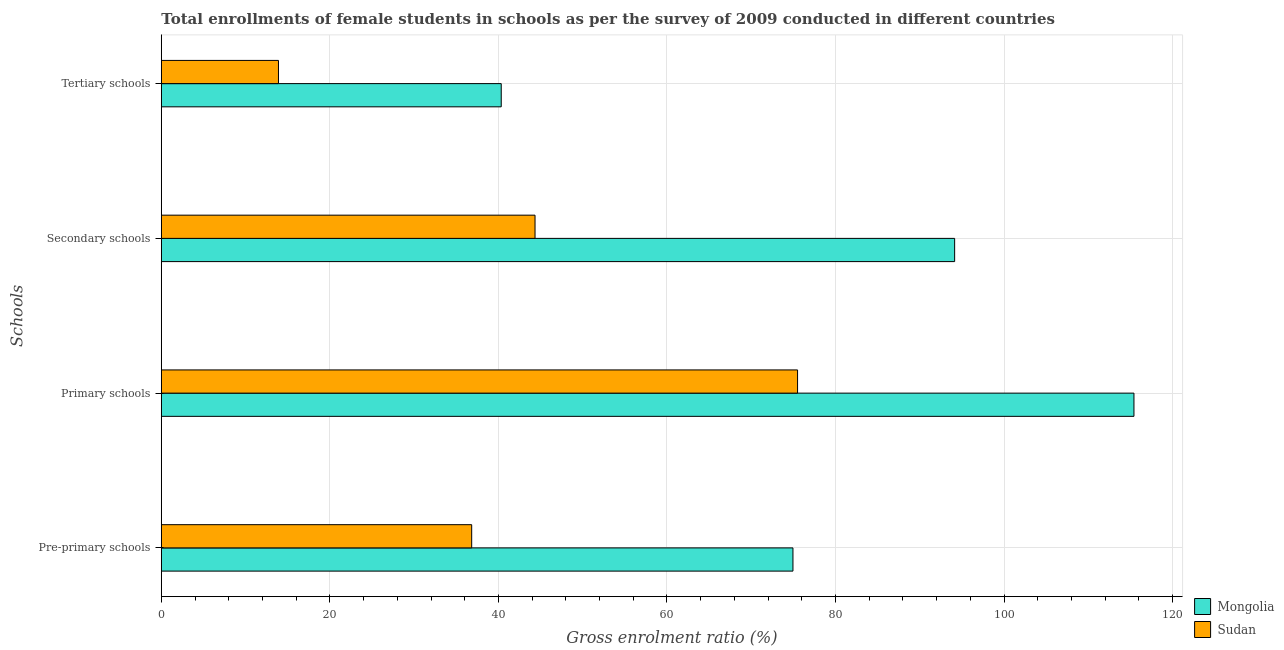How many different coloured bars are there?
Provide a succinct answer. 2. How many groups of bars are there?
Offer a terse response. 4. Are the number of bars on each tick of the Y-axis equal?
Your answer should be compact. Yes. What is the label of the 3rd group of bars from the top?
Offer a very short reply. Primary schools. What is the gross enrolment ratio(female) in primary schools in Sudan?
Keep it short and to the point. 75.5. Across all countries, what is the maximum gross enrolment ratio(female) in pre-primary schools?
Make the answer very short. 74.95. Across all countries, what is the minimum gross enrolment ratio(female) in tertiary schools?
Your response must be concise. 13.9. In which country was the gross enrolment ratio(female) in pre-primary schools maximum?
Your response must be concise. Mongolia. In which country was the gross enrolment ratio(female) in tertiary schools minimum?
Ensure brevity in your answer.  Sudan. What is the total gross enrolment ratio(female) in pre-primary schools in the graph?
Your answer should be very brief. 111.78. What is the difference between the gross enrolment ratio(female) in tertiary schools in Sudan and that in Mongolia?
Your response must be concise. -26.43. What is the difference between the gross enrolment ratio(female) in secondary schools in Sudan and the gross enrolment ratio(female) in tertiary schools in Mongolia?
Your answer should be compact. 4.01. What is the average gross enrolment ratio(female) in primary schools per country?
Provide a succinct answer. 95.46. What is the difference between the gross enrolment ratio(female) in primary schools and gross enrolment ratio(female) in secondary schools in Mongolia?
Your answer should be very brief. 21.28. What is the ratio of the gross enrolment ratio(female) in primary schools in Mongolia to that in Sudan?
Offer a terse response. 1.53. Is the gross enrolment ratio(female) in pre-primary schools in Mongolia less than that in Sudan?
Make the answer very short. No. Is the difference between the gross enrolment ratio(female) in primary schools in Sudan and Mongolia greater than the difference between the gross enrolment ratio(female) in secondary schools in Sudan and Mongolia?
Provide a succinct answer. Yes. What is the difference between the highest and the second highest gross enrolment ratio(female) in pre-primary schools?
Keep it short and to the point. 38.12. What is the difference between the highest and the lowest gross enrolment ratio(female) in pre-primary schools?
Your response must be concise. 38.12. In how many countries, is the gross enrolment ratio(female) in pre-primary schools greater than the average gross enrolment ratio(female) in pre-primary schools taken over all countries?
Your answer should be compact. 1. Is the sum of the gross enrolment ratio(female) in primary schools in Sudan and Mongolia greater than the maximum gross enrolment ratio(female) in secondary schools across all countries?
Offer a very short reply. Yes. What does the 1st bar from the top in Primary schools represents?
Offer a very short reply. Sudan. What does the 2nd bar from the bottom in Pre-primary schools represents?
Give a very brief answer. Sudan. Is it the case that in every country, the sum of the gross enrolment ratio(female) in pre-primary schools and gross enrolment ratio(female) in primary schools is greater than the gross enrolment ratio(female) in secondary schools?
Your response must be concise. Yes. How many bars are there?
Ensure brevity in your answer.  8. Are all the bars in the graph horizontal?
Make the answer very short. Yes. How many countries are there in the graph?
Provide a short and direct response. 2. What is the difference between two consecutive major ticks on the X-axis?
Offer a terse response. 20. Are the values on the major ticks of X-axis written in scientific E-notation?
Ensure brevity in your answer.  No. Does the graph contain any zero values?
Your response must be concise. No. Does the graph contain grids?
Ensure brevity in your answer.  Yes. How many legend labels are there?
Offer a very short reply. 2. How are the legend labels stacked?
Your answer should be very brief. Vertical. What is the title of the graph?
Ensure brevity in your answer.  Total enrollments of female students in schools as per the survey of 2009 conducted in different countries. Does "Japan" appear as one of the legend labels in the graph?
Keep it short and to the point. No. What is the label or title of the X-axis?
Your answer should be very brief. Gross enrolment ratio (%). What is the label or title of the Y-axis?
Provide a short and direct response. Schools. What is the Gross enrolment ratio (%) of Mongolia in Pre-primary schools?
Provide a succinct answer. 74.95. What is the Gross enrolment ratio (%) in Sudan in Pre-primary schools?
Keep it short and to the point. 36.83. What is the Gross enrolment ratio (%) in Mongolia in Primary schools?
Make the answer very short. 115.41. What is the Gross enrolment ratio (%) in Sudan in Primary schools?
Offer a very short reply. 75.5. What is the Gross enrolment ratio (%) of Mongolia in Secondary schools?
Offer a very short reply. 94.14. What is the Gross enrolment ratio (%) in Sudan in Secondary schools?
Offer a very short reply. 44.35. What is the Gross enrolment ratio (%) of Mongolia in Tertiary schools?
Ensure brevity in your answer.  40.33. What is the Gross enrolment ratio (%) in Sudan in Tertiary schools?
Your answer should be compact. 13.9. Across all Schools, what is the maximum Gross enrolment ratio (%) in Mongolia?
Your answer should be compact. 115.41. Across all Schools, what is the maximum Gross enrolment ratio (%) of Sudan?
Offer a very short reply. 75.5. Across all Schools, what is the minimum Gross enrolment ratio (%) in Mongolia?
Ensure brevity in your answer.  40.33. Across all Schools, what is the minimum Gross enrolment ratio (%) in Sudan?
Your response must be concise. 13.9. What is the total Gross enrolment ratio (%) of Mongolia in the graph?
Give a very brief answer. 324.83. What is the total Gross enrolment ratio (%) in Sudan in the graph?
Keep it short and to the point. 170.57. What is the difference between the Gross enrolment ratio (%) in Mongolia in Pre-primary schools and that in Primary schools?
Provide a short and direct response. -40.46. What is the difference between the Gross enrolment ratio (%) in Sudan in Pre-primary schools and that in Primary schools?
Offer a very short reply. -38.67. What is the difference between the Gross enrolment ratio (%) of Mongolia in Pre-primary schools and that in Secondary schools?
Provide a succinct answer. -19.19. What is the difference between the Gross enrolment ratio (%) in Sudan in Pre-primary schools and that in Secondary schools?
Offer a terse response. -7.52. What is the difference between the Gross enrolment ratio (%) in Mongolia in Pre-primary schools and that in Tertiary schools?
Provide a succinct answer. 34.62. What is the difference between the Gross enrolment ratio (%) in Sudan in Pre-primary schools and that in Tertiary schools?
Offer a terse response. 22.93. What is the difference between the Gross enrolment ratio (%) of Mongolia in Primary schools and that in Secondary schools?
Ensure brevity in your answer.  21.28. What is the difference between the Gross enrolment ratio (%) in Sudan in Primary schools and that in Secondary schools?
Your response must be concise. 31.15. What is the difference between the Gross enrolment ratio (%) in Mongolia in Primary schools and that in Tertiary schools?
Provide a short and direct response. 75.08. What is the difference between the Gross enrolment ratio (%) of Sudan in Primary schools and that in Tertiary schools?
Make the answer very short. 61.6. What is the difference between the Gross enrolment ratio (%) in Mongolia in Secondary schools and that in Tertiary schools?
Ensure brevity in your answer.  53.8. What is the difference between the Gross enrolment ratio (%) of Sudan in Secondary schools and that in Tertiary schools?
Your answer should be very brief. 30.44. What is the difference between the Gross enrolment ratio (%) of Mongolia in Pre-primary schools and the Gross enrolment ratio (%) of Sudan in Primary schools?
Make the answer very short. -0.55. What is the difference between the Gross enrolment ratio (%) of Mongolia in Pre-primary schools and the Gross enrolment ratio (%) of Sudan in Secondary schools?
Provide a short and direct response. 30.6. What is the difference between the Gross enrolment ratio (%) in Mongolia in Pre-primary schools and the Gross enrolment ratio (%) in Sudan in Tertiary schools?
Provide a succinct answer. 61.05. What is the difference between the Gross enrolment ratio (%) in Mongolia in Primary schools and the Gross enrolment ratio (%) in Sudan in Secondary schools?
Your response must be concise. 71.07. What is the difference between the Gross enrolment ratio (%) in Mongolia in Primary schools and the Gross enrolment ratio (%) in Sudan in Tertiary schools?
Ensure brevity in your answer.  101.51. What is the difference between the Gross enrolment ratio (%) in Mongolia in Secondary schools and the Gross enrolment ratio (%) in Sudan in Tertiary schools?
Offer a very short reply. 80.23. What is the average Gross enrolment ratio (%) of Mongolia per Schools?
Your answer should be compact. 81.21. What is the average Gross enrolment ratio (%) in Sudan per Schools?
Ensure brevity in your answer.  42.64. What is the difference between the Gross enrolment ratio (%) in Mongolia and Gross enrolment ratio (%) in Sudan in Pre-primary schools?
Give a very brief answer. 38.12. What is the difference between the Gross enrolment ratio (%) of Mongolia and Gross enrolment ratio (%) of Sudan in Primary schools?
Give a very brief answer. 39.92. What is the difference between the Gross enrolment ratio (%) of Mongolia and Gross enrolment ratio (%) of Sudan in Secondary schools?
Your answer should be compact. 49.79. What is the difference between the Gross enrolment ratio (%) of Mongolia and Gross enrolment ratio (%) of Sudan in Tertiary schools?
Offer a terse response. 26.43. What is the ratio of the Gross enrolment ratio (%) of Mongolia in Pre-primary schools to that in Primary schools?
Keep it short and to the point. 0.65. What is the ratio of the Gross enrolment ratio (%) of Sudan in Pre-primary schools to that in Primary schools?
Offer a terse response. 0.49. What is the ratio of the Gross enrolment ratio (%) in Mongolia in Pre-primary schools to that in Secondary schools?
Ensure brevity in your answer.  0.8. What is the ratio of the Gross enrolment ratio (%) of Sudan in Pre-primary schools to that in Secondary schools?
Provide a short and direct response. 0.83. What is the ratio of the Gross enrolment ratio (%) in Mongolia in Pre-primary schools to that in Tertiary schools?
Offer a terse response. 1.86. What is the ratio of the Gross enrolment ratio (%) of Sudan in Pre-primary schools to that in Tertiary schools?
Keep it short and to the point. 2.65. What is the ratio of the Gross enrolment ratio (%) of Mongolia in Primary schools to that in Secondary schools?
Keep it short and to the point. 1.23. What is the ratio of the Gross enrolment ratio (%) in Sudan in Primary schools to that in Secondary schools?
Offer a terse response. 1.7. What is the ratio of the Gross enrolment ratio (%) in Mongolia in Primary schools to that in Tertiary schools?
Offer a terse response. 2.86. What is the ratio of the Gross enrolment ratio (%) in Sudan in Primary schools to that in Tertiary schools?
Keep it short and to the point. 5.43. What is the ratio of the Gross enrolment ratio (%) in Mongolia in Secondary schools to that in Tertiary schools?
Provide a succinct answer. 2.33. What is the ratio of the Gross enrolment ratio (%) in Sudan in Secondary schools to that in Tertiary schools?
Make the answer very short. 3.19. What is the difference between the highest and the second highest Gross enrolment ratio (%) of Mongolia?
Ensure brevity in your answer.  21.28. What is the difference between the highest and the second highest Gross enrolment ratio (%) of Sudan?
Ensure brevity in your answer.  31.15. What is the difference between the highest and the lowest Gross enrolment ratio (%) of Mongolia?
Offer a very short reply. 75.08. What is the difference between the highest and the lowest Gross enrolment ratio (%) of Sudan?
Your answer should be compact. 61.6. 